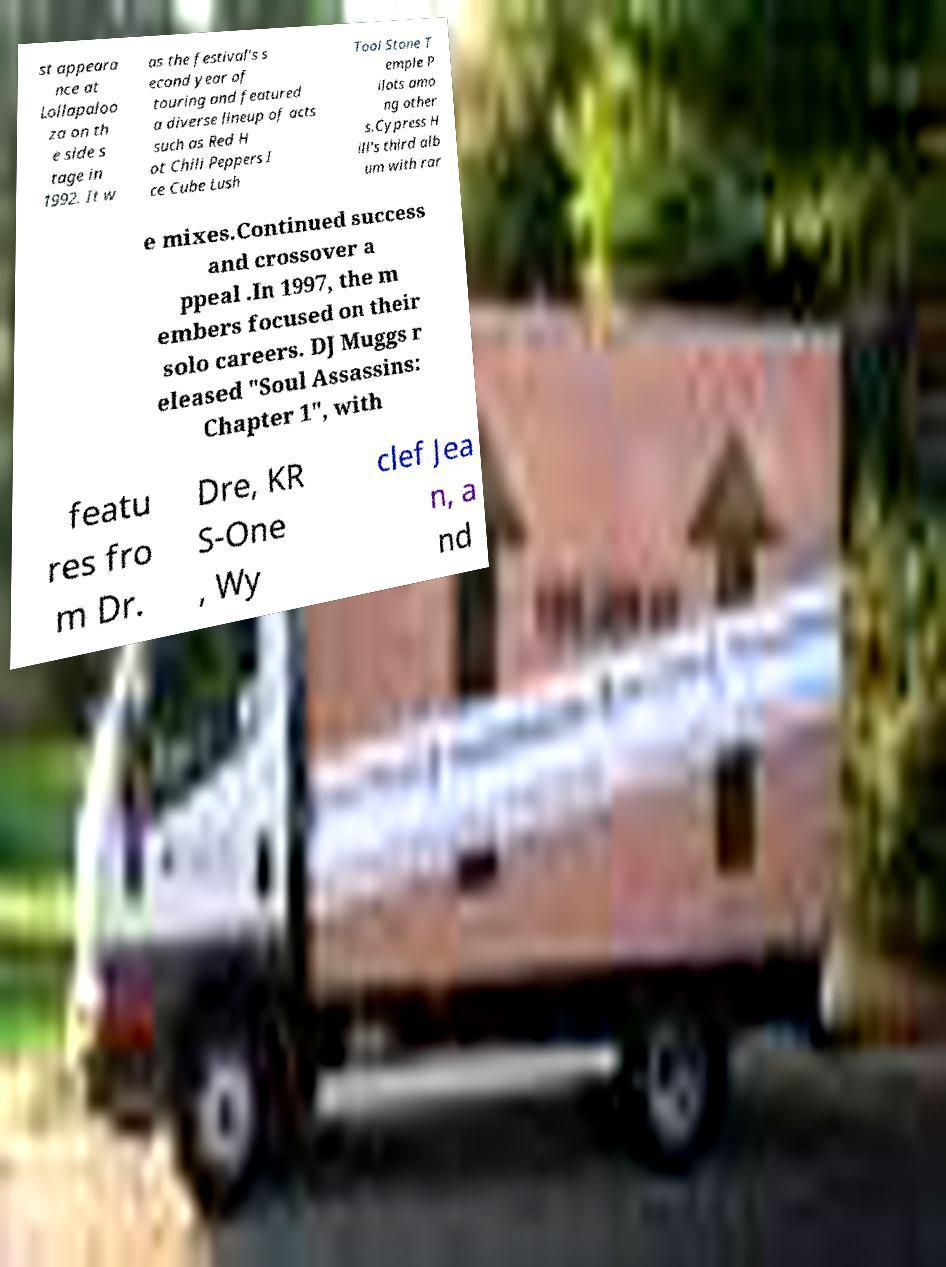Can you accurately transcribe the text from the provided image for me? st appeara nce at Lollapaloo za on th e side s tage in 1992. It w as the festival's s econd year of touring and featured a diverse lineup of acts such as Red H ot Chili Peppers I ce Cube Lush Tool Stone T emple P ilots amo ng other s.Cypress H ill's third alb um with rar e mixes.Continued success and crossover a ppeal .In 1997, the m embers focused on their solo careers. DJ Muggs r eleased "Soul Assassins: Chapter 1", with featu res fro m Dr. Dre, KR S-One , Wy clef Jea n, a nd 